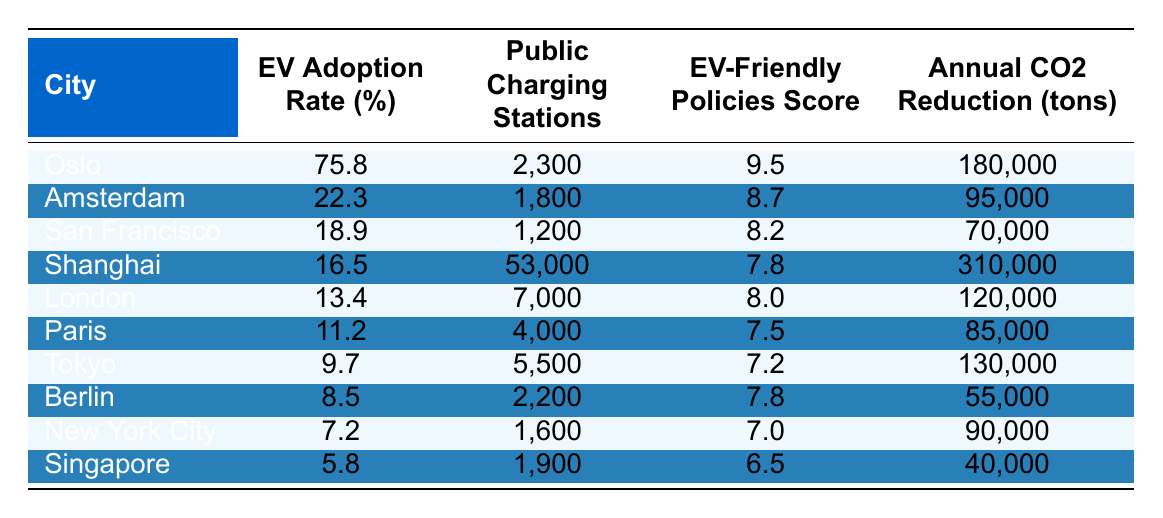What is the EV adoption rate in Oslo? The table lists the EV adoption rate for Oslo as 75.8%.
Answer: 75.8% How many public charging stations are available in Amsterdam? The table shows that there are 1,800 public charging stations in Amsterdam.
Answer: 1,800 What is the difference in EV adoption rates between Shanghai and San Francisco? Shanghai has an EV adoption rate of 16.5% and San Francisco has a rate of 18.9%. The difference is 18.9% - 16.5% = 2.4%.
Answer: 2.4% Which city has the highest annual CO2 reduction and what is that amount? The city with the highest annual CO2 reduction is Shanghai, with a reduction of 310,000 tons.
Answer: 310,000 tons Is the EV-friendly policies score for London higher than that of Paris? London has a score of 8.0, while Paris has a score of 7.5. Thus, London's score is higher.
Answer: Yes What are the average EV adoption rates for the top three cities with the highest adoption rates? The top three cities are Oslo (75.8%), Amsterdam (22.3%), and San Francisco (18.9%). The average is (75.8 + 22.3 + 18.9) / 3 = 38.333.
Answer: 38.333 How does the number of public charging stations in Berlin compare to that in New York City? Berlin has 2,200 public charging stations, while New York City has 1,600. Comparing 2,200 and 1,600, Berlin has more charging stations.
Answer: Berlin has more Identify the city with the lowest EV adoption rate and provide its value. The city with the lowest EV adoption rate is Singapore at 5.8%.
Answer: 5.8% What is the total annual CO2 reduction for the cities with an EV adoption rate above 15%? The cities are Oslo (180,000 tons), Amsterdam (95,000 tons), San Francisco (70,000 tons), and Shanghai (310,000 tons). Summing these gives 180,000 + 95,000 + 70,000 + 310,000 = 655,000 tons.
Answer: 655,000 tons If we consider only cities with an EV adoption rate above 10%, what is the median EV adoption rate of these cities? The cities with EV adoption rates above 10% are Oslo (75.8%), Amsterdam (22.3%), San Francisco (18.9%), Shanghai (16.5%), London (13.4%), and Paris (11.2%). Sorting these yields 11.2%, 13.4%, 16.5%, 18.9%, 22.3%, 75.8%. The median is (16.5% + 18.9%) / 2 = 17.7%.
Answer: 17.7% 